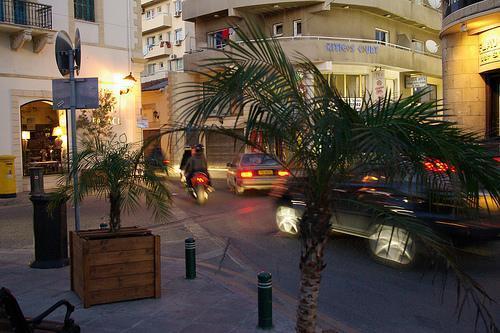How many palm trees are toward the right side of the image?
Give a very brief answer. 1. 